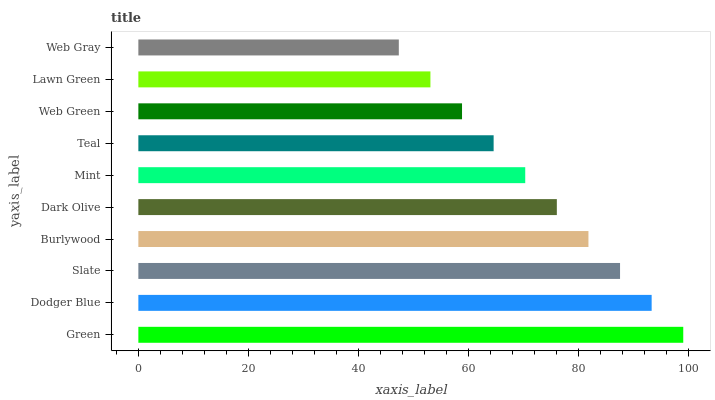Is Web Gray the minimum?
Answer yes or no. Yes. Is Green the maximum?
Answer yes or no. Yes. Is Dodger Blue the minimum?
Answer yes or no. No. Is Dodger Blue the maximum?
Answer yes or no. No. Is Green greater than Dodger Blue?
Answer yes or no. Yes. Is Dodger Blue less than Green?
Answer yes or no. Yes. Is Dodger Blue greater than Green?
Answer yes or no. No. Is Green less than Dodger Blue?
Answer yes or no. No. Is Dark Olive the high median?
Answer yes or no. Yes. Is Mint the low median?
Answer yes or no. Yes. Is Teal the high median?
Answer yes or no. No. Is Slate the low median?
Answer yes or no. No. 